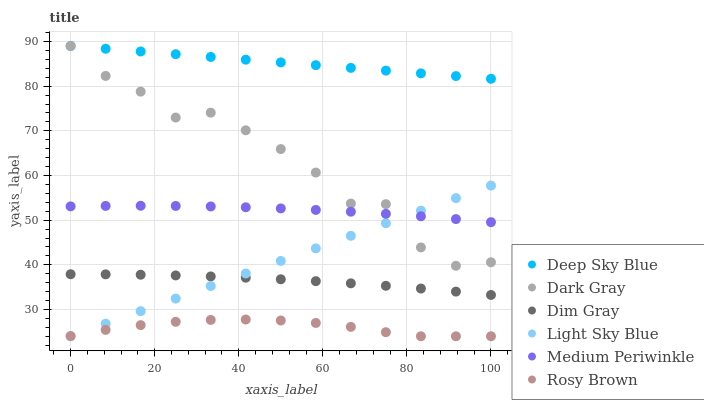Does Rosy Brown have the minimum area under the curve?
Answer yes or no. Yes. Does Deep Sky Blue have the maximum area under the curve?
Answer yes or no. Yes. Does Medium Periwinkle have the minimum area under the curve?
Answer yes or no. No. Does Medium Periwinkle have the maximum area under the curve?
Answer yes or no. No. Is Deep Sky Blue the smoothest?
Answer yes or no. Yes. Is Dark Gray the roughest?
Answer yes or no. Yes. Is Rosy Brown the smoothest?
Answer yes or no. No. Is Rosy Brown the roughest?
Answer yes or no. No. Does Rosy Brown have the lowest value?
Answer yes or no. Yes. Does Medium Periwinkle have the lowest value?
Answer yes or no. No. Does Deep Sky Blue have the highest value?
Answer yes or no. Yes. Does Medium Periwinkle have the highest value?
Answer yes or no. No. Is Rosy Brown less than Dim Gray?
Answer yes or no. Yes. Is Deep Sky Blue greater than Rosy Brown?
Answer yes or no. Yes. Does Light Sky Blue intersect Rosy Brown?
Answer yes or no. Yes. Is Light Sky Blue less than Rosy Brown?
Answer yes or no. No. Is Light Sky Blue greater than Rosy Brown?
Answer yes or no. No. Does Rosy Brown intersect Dim Gray?
Answer yes or no. No. 